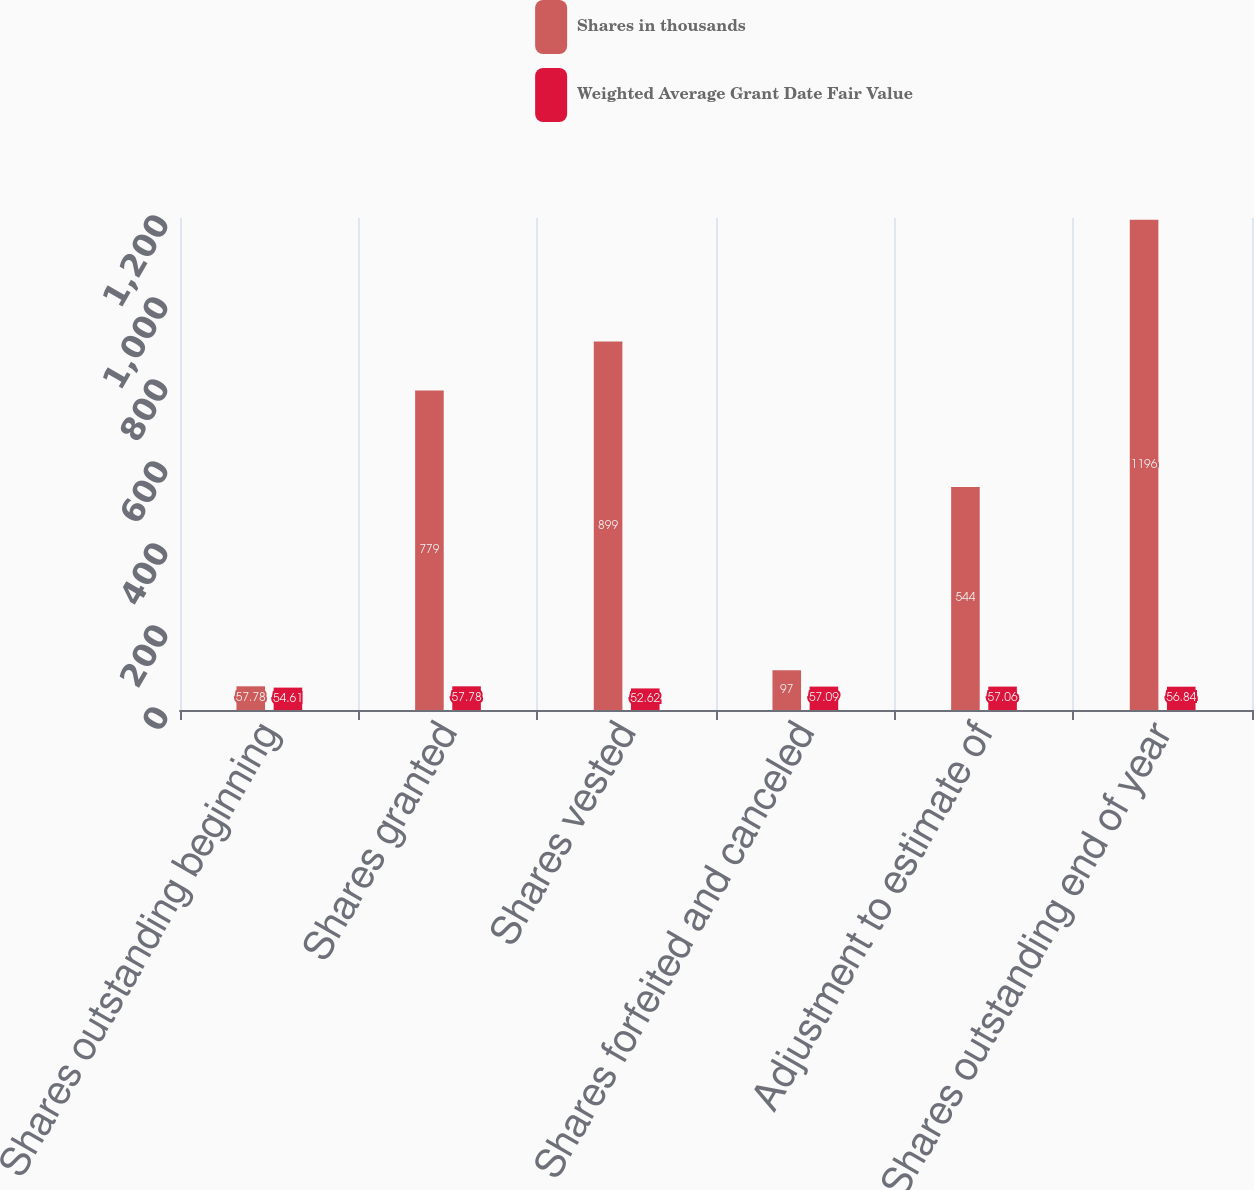Convert chart to OTSL. <chart><loc_0><loc_0><loc_500><loc_500><stacked_bar_chart><ecel><fcel>Shares outstanding beginning<fcel>Shares granted<fcel>Shares vested<fcel>Shares forfeited and canceled<fcel>Adjustment to estimate of<fcel>Shares outstanding end of year<nl><fcel>Shares in thousands<fcel>57.78<fcel>779<fcel>899<fcel>97<fcel>544<fcel>1196<nl><fcel>Weighted Average Grant Date Fair Value<fcel>54.61<fcel>57.78<fcel>52.62<fcel>57.09<fcel>57.06<fcel>56.84<nl></chart> 